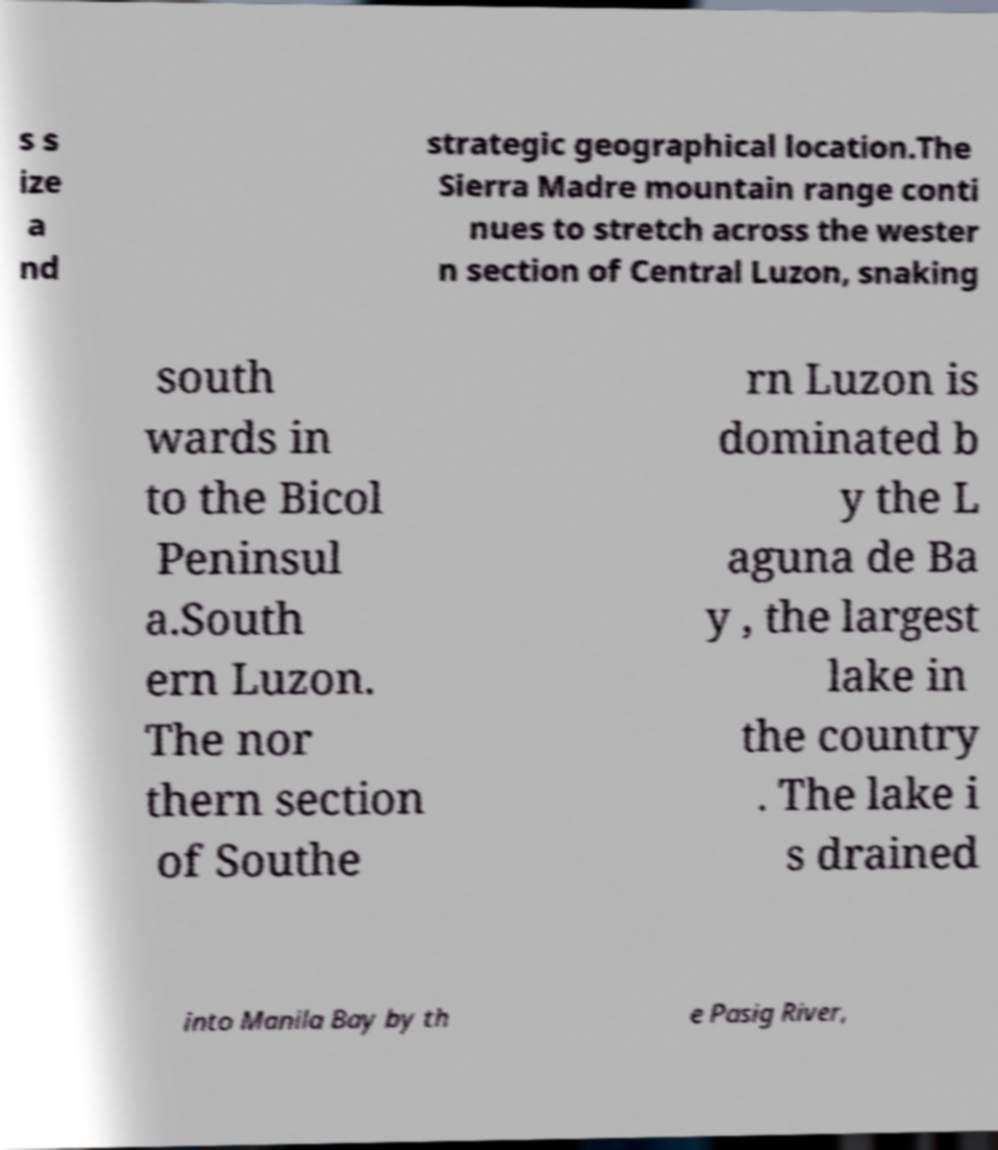Could you assist in decoding the text presented in this image and type it out clearly? s s ize a nd strategic geographical location.The Sierra Madre mountain range conti nues to stretch across the wester n section of Central Luzon, snaking south wards in to the Bicol Peninsul a.South ern Luzon. The nor thern section of Southe rn Luzon is dominated b y the L aguna de Ba y , the largest lake in the country . The lake i s drained into Manila Bay by th e Pasig River, 